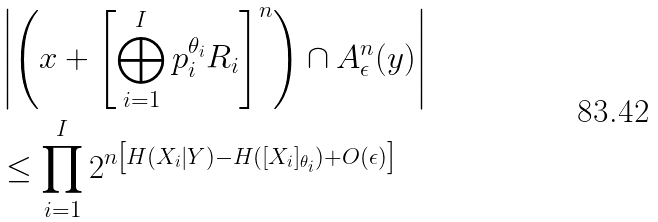Convert formula to latex. <formula><loc_0><loc_0><loc_500><loc_500>& \left | \left ( x + \left [ \bigoplus _ { i = 1 } ^ { I } p _ { i } ^ { \theta _ { i } } R _ { i } \right ] ^ { n } \right ) \cap A _ { \epsilon } ^ { n } ( y ) \right | \\ & \leq \prod _ { i = 1 } ^ { I } 2 ^ { n \left [ H ( X _ { i } | Y ) - H ( [ X _ { i } ] _ { \theta _ { i } } ) + O ( \epsilon ) \right ] }</formula> 